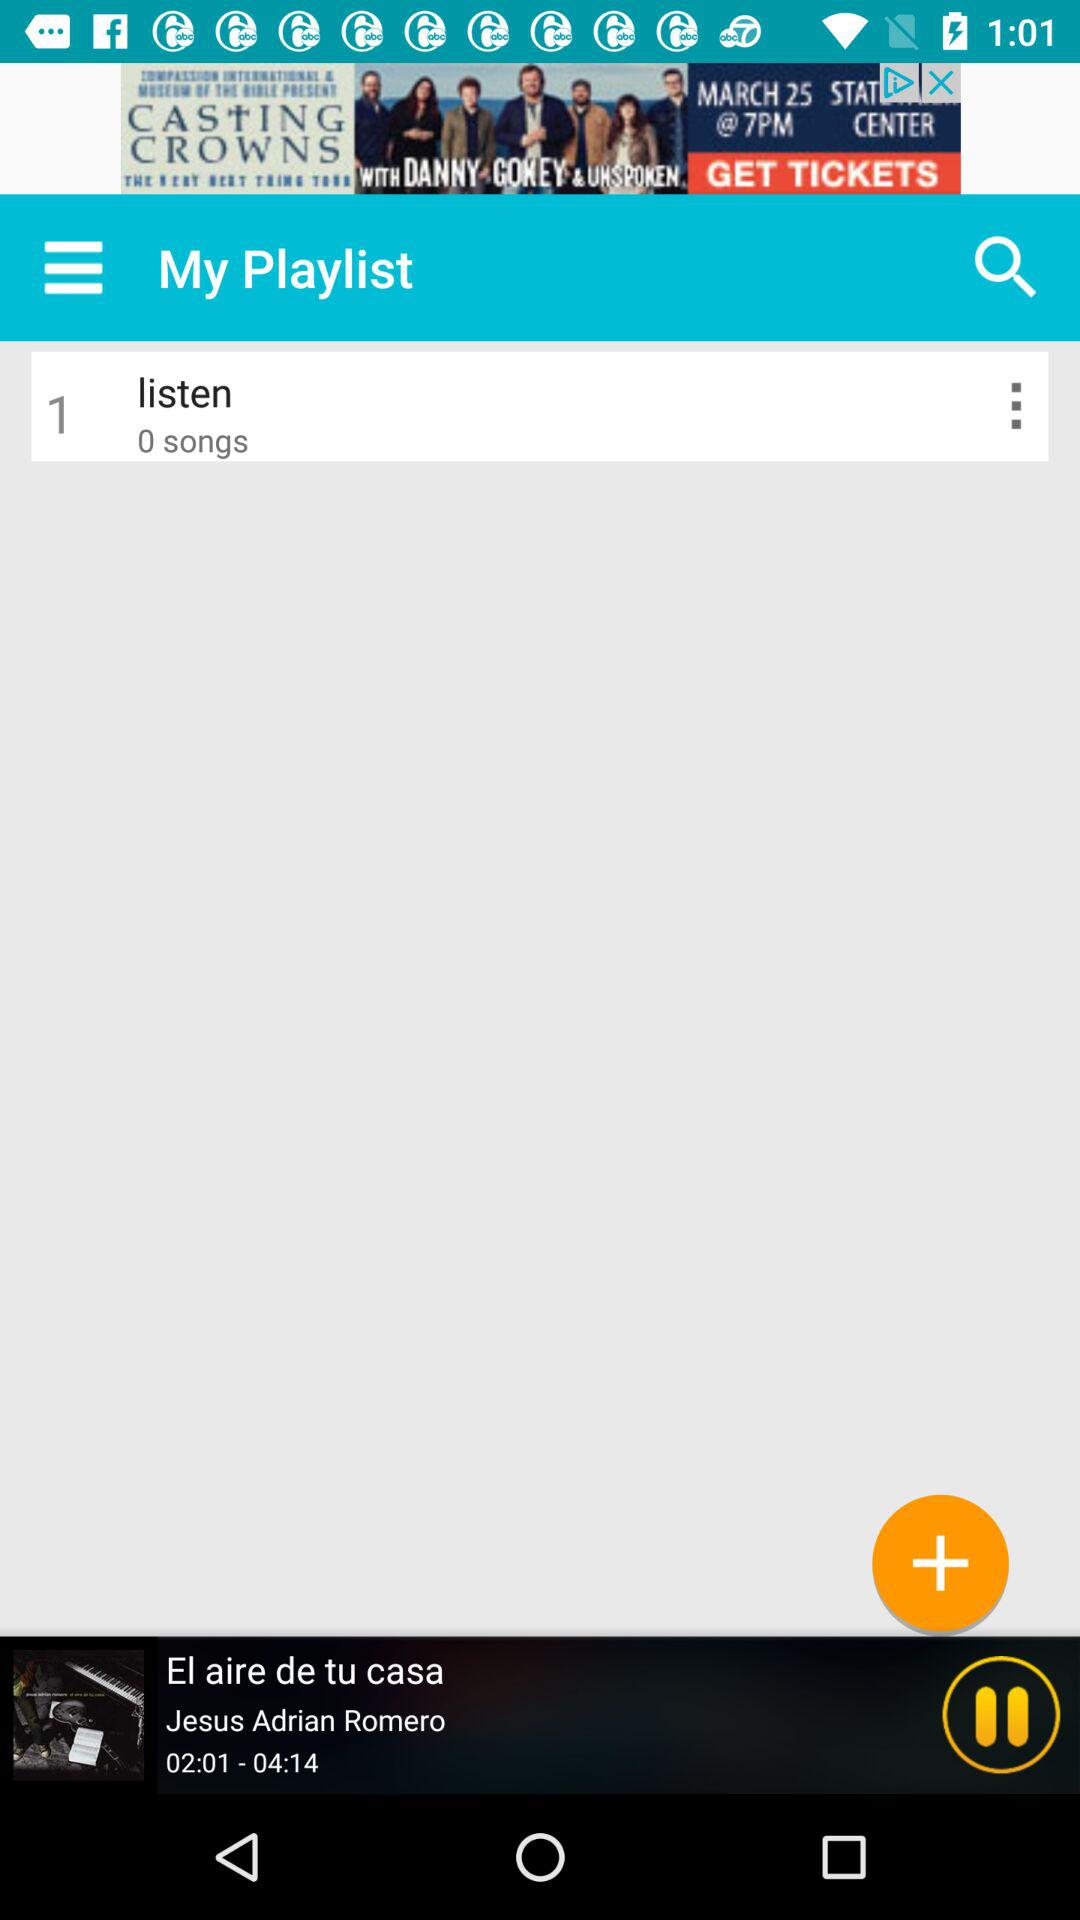What is the duration of the song? The duration of the song is 04:14. 